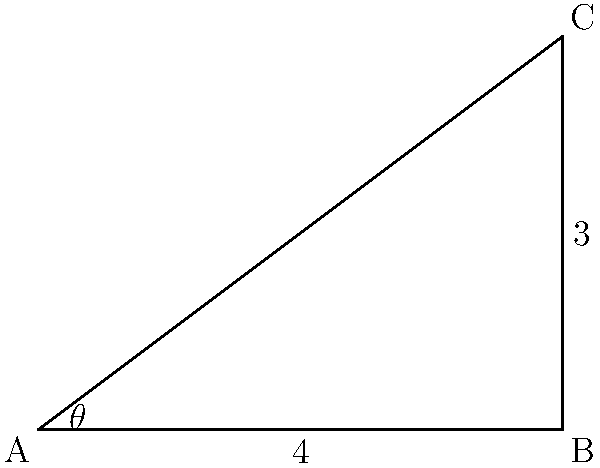During a specific synchronized swimming move, a swimmer's arm forms a right-angled triangle with the water surface. If the arm extends 4 meters horizontally and 3 meters vertically from the shoulder, what is the angle $\theta$ between the arm and the water surface? To solve this problem, we'll use trigonometry:

1) We have a right-angled triangle ABC, where:
   - AB is the horizontal distance (4 meters)
   - BC is the vertical distance (3 meters)
   - AC is the swimmer's arm
   - $\theta$ is the angle between the arm and the water surface

2) We need to find $\theta$. We can use the arctangent function for this.

3) In a right-angled triangle, $\tan(\theta) = \frac{\text{opposite}}{\text{adjacent}}$

4) Here, $\tan(\theta) = \frac{BC}{AB} = \frac{3}{4}$

5) Therefore, $\theta = \arctan(\frac{3}{4})$

6) Using a calculator or computer:
   $\theta \approx 36.87°$

7) Rounding to the nearest degree: $\theta \approx 37°$
Answer: $37°$ 